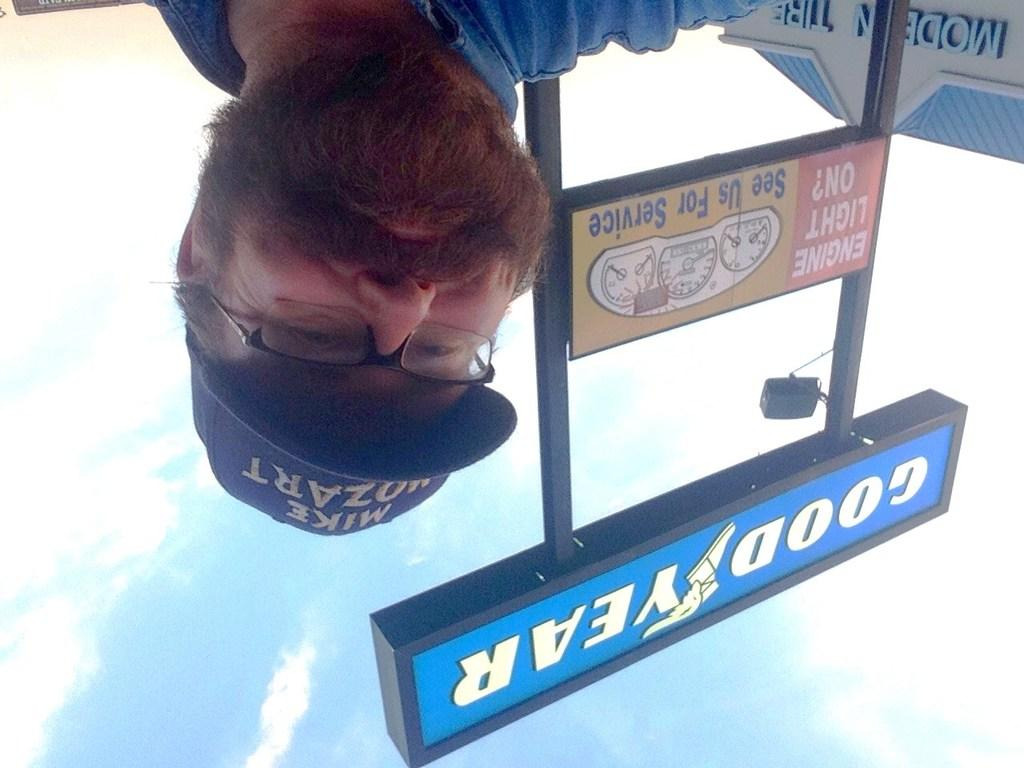What is the person in the image wearing on their head? There is a person with a cap in the image. What is written on the board in the image? There is a board with text in the image. How is the board illuminated in the image? A light is attached to the board. What can be seen in the background of the image? There is a building with text in the background of the image, and the sky is visible. What is the weather like in the image? Clouds are present in the sky, indicating that it might be partly cloudy. What type of wood is used to construct the farm in the image? There is no farm present in the image, so it is not possible to determine the type of wood used in its construction. 